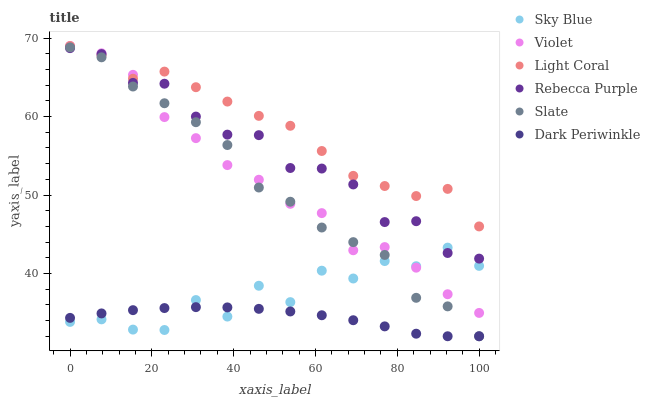Does Dark Periwinkle have the minimum area under the curve?
Answer yes or no. Yes. Does Light Coral have the maximum area under the curve?
Answer yes or no. Yes. Does Rebecca Purple have the minimum area under the curve?
Answer yes or no. No. Does Rebecca Purple have the maximum area under the curve?
Answer yes or no. No. Is Dark Periwinkle the smoothest?
Answer yes or no. Yes. Is Sky Blue the roughest?
Answer yes or no. Yes. Is Light Coral the smoothest?
Answer yes or no. No. Is Light Coral the roughest?
Answer yes or no. No. Does Slate have the lowest value?
Answer yes or no. Yes. Does Rebecca Purple have the lowest value?
Answer yes or no. No. Does Violet have the highest value?
Answer yes or no. Yes. Does Rebecca Purple have the highest value?
Answer yes or no. No. Is Sky Blue less than Light Coral?
Answer yes or no. Yes. Is Light Coral greater than Slate?
Answer yes or no. Yes. Does Dark Periwinkle intersect Slate?
Answer yes or no. Yes. Is Dark Periwinkle less than Slate?
Answer yes or no. No. Is Dark Periwinkle greater than Slate?
Answer yes or no. No. Does Sky Blue intersect Light Coral?
Answer yes or no. No. 